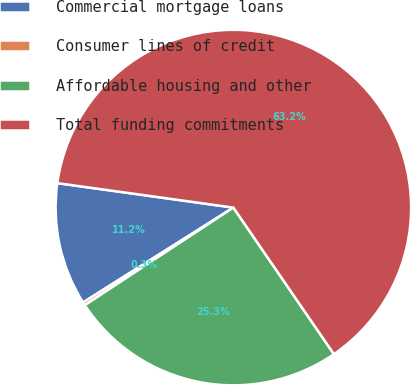Convert chart to OTSL. <chart><loc_0><loc_0><loc_500><loc_500><pie_chart><fcel>Commercial mortgage loans<fcel>Consumer lines of credit<fcel>Affordable housing and other<fcel>Total funding commitments<nl><fcel>11.16%<fcel>0.29%<fcel>25.32%<fcel>63.23%<nl></chart> 